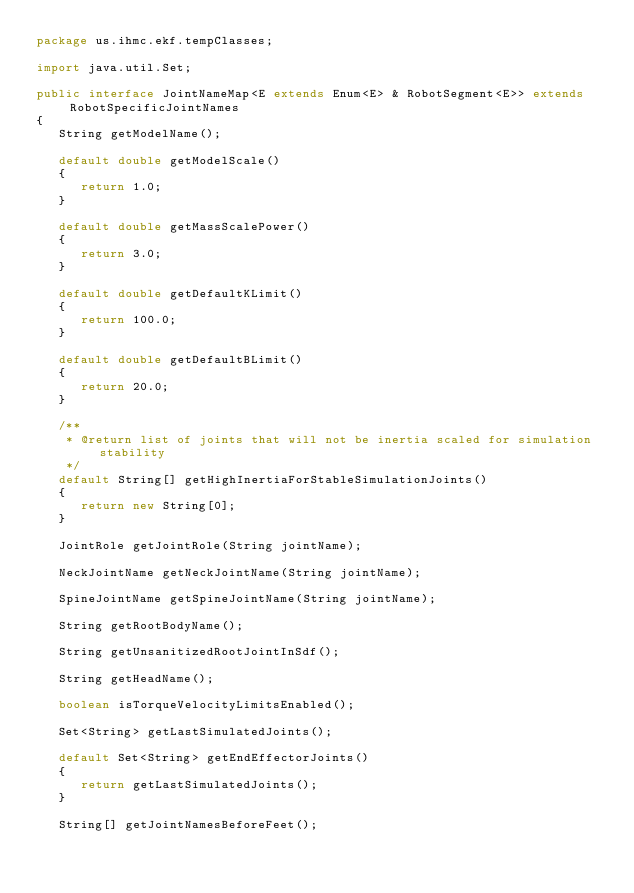<code> <loc_0><loc_0><loc_500><loc_500><_Java_>package us.ihmc.ekf.tempClasses;

import java.util.Set;

public interface JointNameMap<E extends Enum<E> & RobotSegment<E>> extends RobotSpecificJointNames
{
   String getModelName();

   default double getModelScale()
   {
      return 1.0;
   }

   default double getMassScalePower()
   {
      return 3.0;
   }

   default double getDefaultKLimit()
   {
      return 100.0;
   }

   default double getDefaultBLimit()
   {
      return 20.0;
   }

   /**
    * @return list of joints that will not be inertia scaled for simulation stability
    */
   default String[] getHighInertiaForStableSimulationJoints()
   {
      return new String[0];
   }

   JointRole getJointRole(String jointName);

   NeckJointName getNeckJointName(String jointName);

   SpineJointName getSpineJointName(String jointName);

   String getRootBodyName();

   String getUnsanitizedRootJointInSdf();

   String getHeadName();

   boolean isTorqueVelocityLimitsEnabled();

   Set<String> getLastSimulatedJoints();

   default Set<String> getEndEffectorJoints()
   {
      return getLastSimulatedJoints();
   }

   String[] getJointNamesBeforeFeet();
</code> 